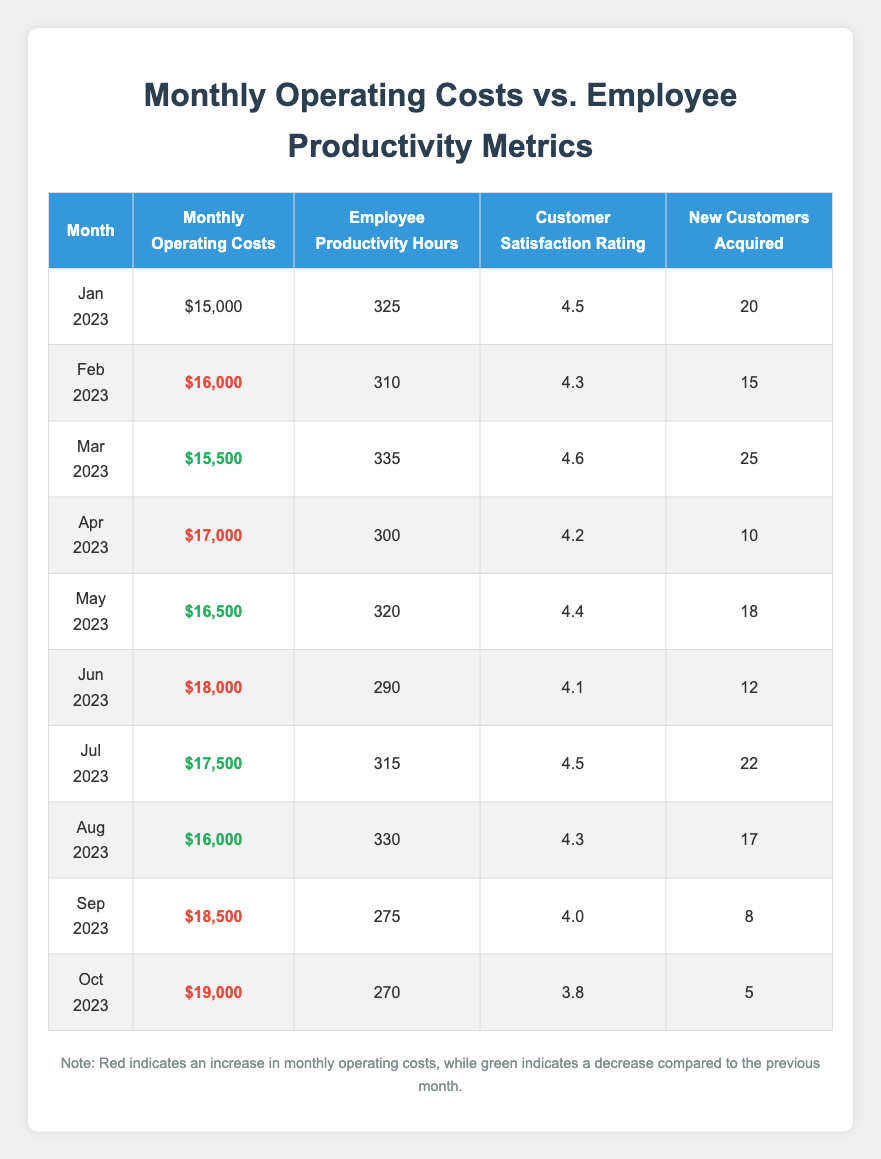What were the monthly operating costs in February 2023? The table states the monthly operating costs for February 2023 as $16,000.
Answer: $16,000 Which month had the highest customer satisfaction rating? Looking through the customer satisfaction rating column, the highest rating is 4.6, which occurred in March 2023.
Answer: March 2023 How much did monthly operating costs increase from January to February? The operating costs in January were $15,000 and in February they were $16,000. The increase is calculated as $16,000 - $15,000 = $1,000.
Answer: $1,000 Did employee productivity hours decrease in July 2023 compared to June 2023? In June 2023, employee productivity hours were 290, and in July 2023, they were 315. Since 315 is greater than 290, productivity hours did not decrease; they increased.
Answer: No What was the average customer satisfaction rating over the 10 months? The customer satisfaction ratings are 4.5, 4.3, 4.6, 4.2, 4.4, 4.1, 4.5, 4.3, 4.0, and 3.8. Summing these ratings gives 4.5 + 4.3 + 4.6 + 4.2 + 4.4 + 4.1 + 4.5 + 4.3 + 4.0 + 3.8 = 43.7. Then, dividing by 10 (the number of months) gives an average of 43.7 / 10 = 4.37.
Answer: 4.37 How many new customers were acquired in total from January to October 2023? The new customers acquired each month are 20, 15, 25, 10, 18, 12, 22, 17, 8, and 5. Summing these gives 20 + 15 + 25 + 10 + 18 + 12 + 22 + 17 + 8 + 5 = 182.
Answer: 182 In which month did operating costs exceed $18,000? By reviewing the operating costs column, we see that they exceeded $18,000 in June ($18,000), September ($18,500), and October ($19,000). The first month where this occurred was June 2023.
Answer: June 2023 What trend do we see in employee productivity hours from January to October? To identify the trend, we can look at the values: 325, 310, 335, 300, 320, 290, 315, 330, 275, 270. Overall, we notice fluctuations — it decreases from January to February and then fluctuates up and down but ends with a general decline towards October.
Answer: Fluctuating downward trend Was there any month where both operating costs and customer satisfaction ratings increased from the previous month? By checking the table, we see that for April 2023, operating costs increased to $17,000 from $15,500 in March, but customer satisfaction decreased from 4.6 to 4.2. Therefore, there was no month where both metrics increased simultaneously.
Answer: No 